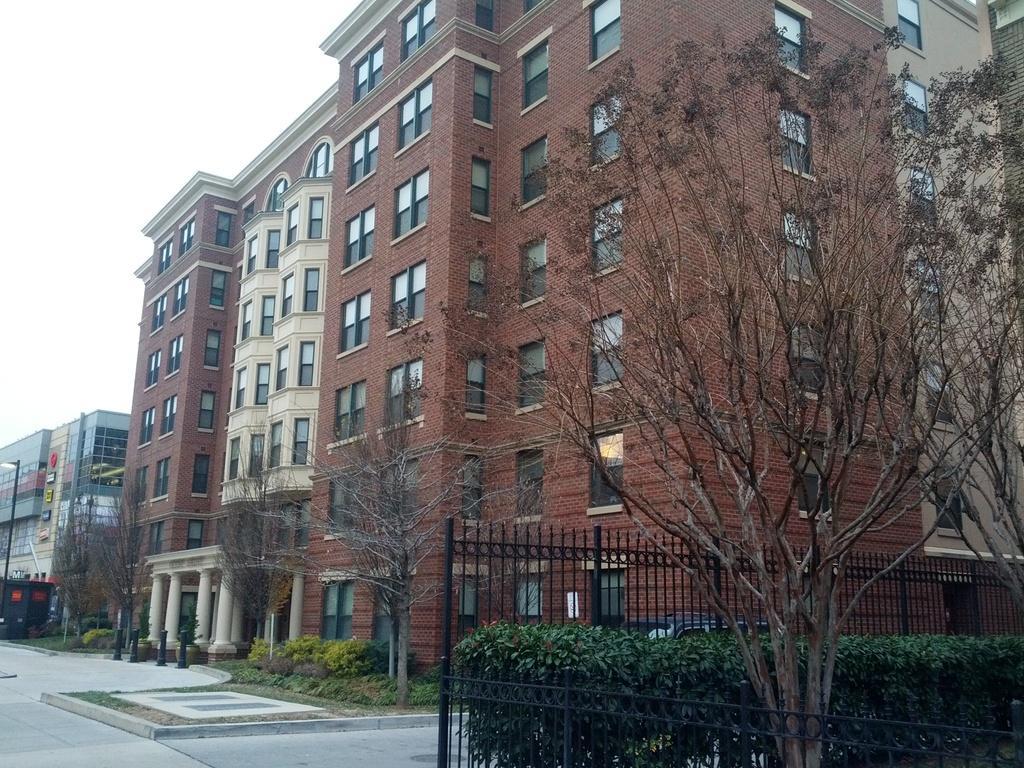How would you summarize this image in a sentence or two? In this image we can see a group of buildings, trees, plants and fencing. In the top left, we can see the sky. 